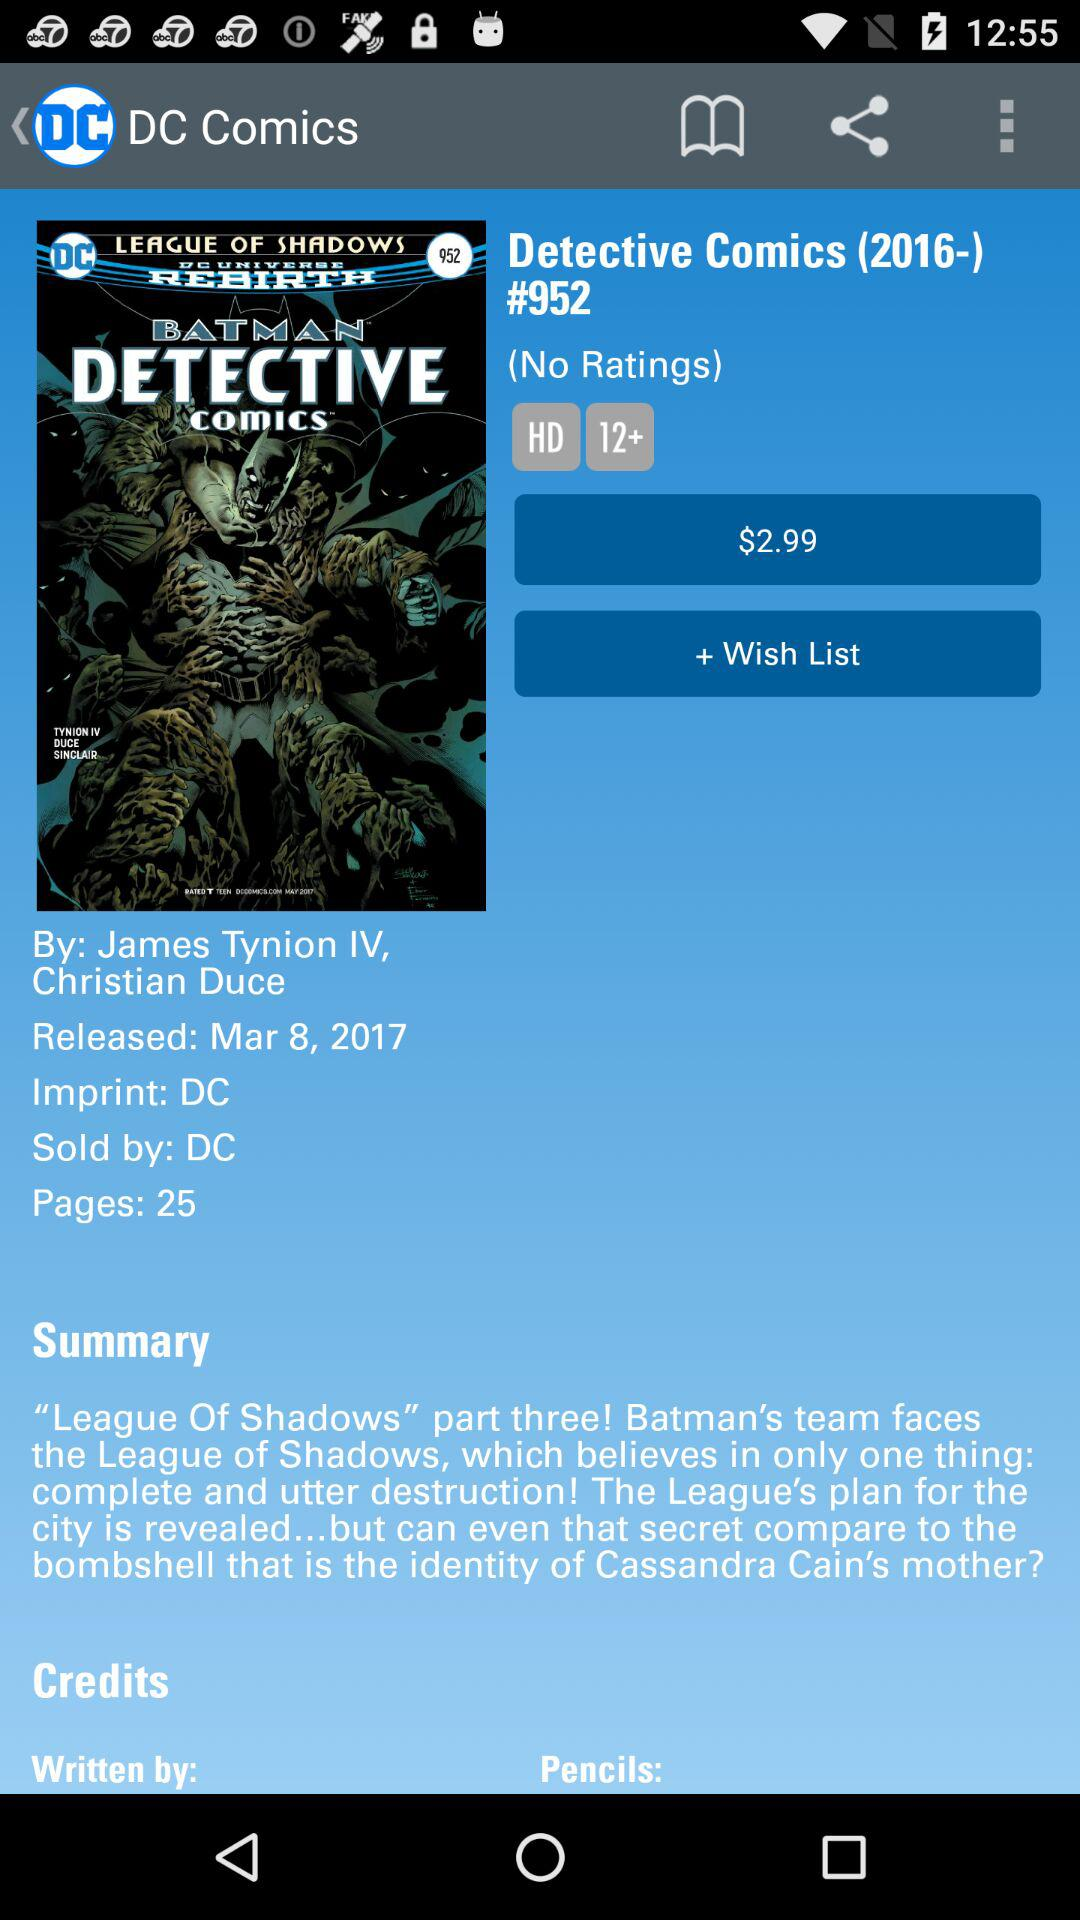How many ratings are there? There are no ratings. 